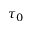Convert formula to latex. <formula><loc_0><loc_0><loc_500><loc_500>\tau _ { 0 }</formula> 